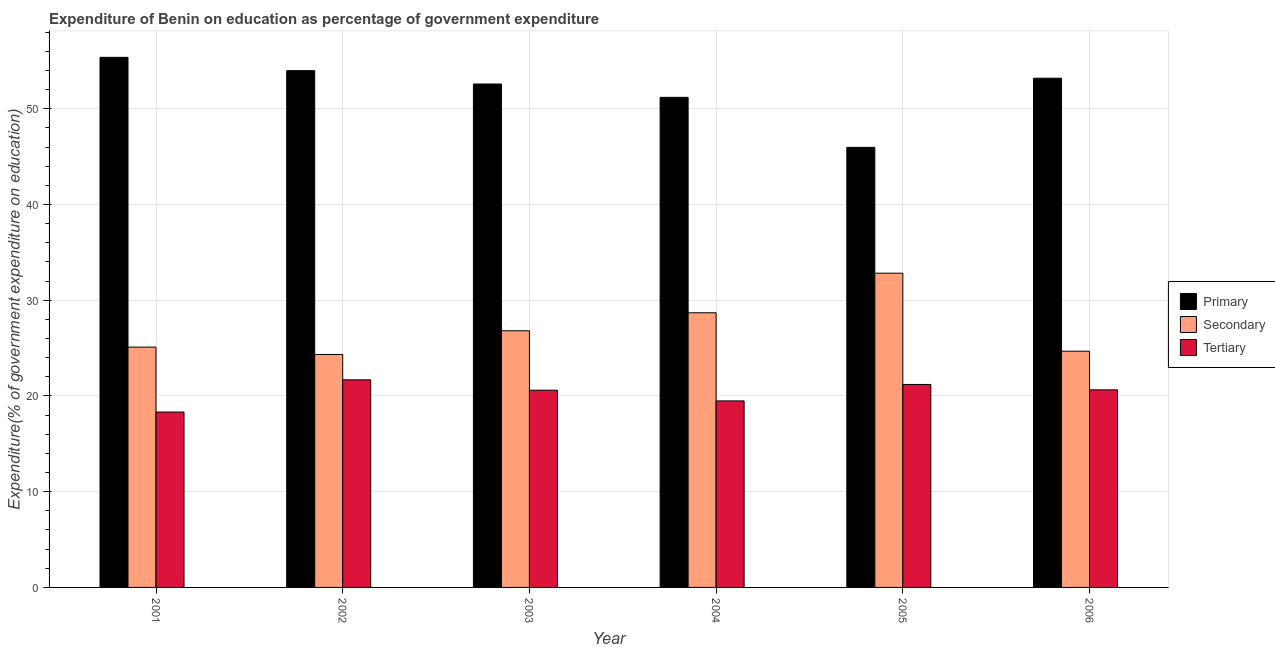How many different coloured bars are there?
Offer a very short reply. 3. How many groups of bars are there?
Keep it short and to the point. 6. Are the number of bars on each tick of the X-axis equal?
Ensure brevity in your answer.  Yes. What is the expenditure on secondary education in 2006?
Offer a very short reply. 24.68. Across all years, what is the maximum expenditure on secondary education?
Offer a terse response. 32.83. Across all years, what is the minimum expenditure on secondary education?
Ensure brevity in your answer.  24.33. In which year was the expenditure on secondary education minimum?
Give a very brief answer. 2002. What is the total expenditure on tertiary education in the graph?
Your response must be concise. 121.93. What is the difference between the expenditure on tertiary education in 2001 and that in 2002?
Your response must be concise. -3.37. What is the difference between the expenditure on primary education in 2004 and the expenditure on secondary education in 2005?
Keep it short and to the point. 5.23. What is the average expenditure on primary education per year?
Provide a succinct answer. 52.05. In how many years, is the expenditure on secondary education greater than 32 %?
Your answer should be compact. 1. What is the ratio of the expenditure on tertiary education in 2001 to that in 2005?
Keep it short and to the point. 0.86. Is the expenditure on secondary education in 2001 less than that in 2003?
Make the answer very short. Yes. What is the difference between the highest and the second highest expenditure on secondary education?
Provide a short and direct response. 4.14. What is the difference between the highest and the lowest expenditure on primary education?
Your response must be concise. 9.4. In how many years, is the expenditure on secondary education greater than the average expenditure on secondary education taken over all years?
Offer a terse response. 2. Is the sum of the expenditure on secondary education in 2001 and 2006 greater than the maximum expenditure on tertiary education across all years?
Give a very brief answer. Yes. What does the 3rd bar from the left in 2003 represents?
Offer a very short reply. Tertiary. What does the 2nd bar from the right in 2001 represents?
Your answer should be compact. Secondary. Does the graph contain grids?
Offer a terse response. Yes. How many legend labels are there?
Your response must be concise. 3. What is the title of the graph?
Offer a terse response. Expenditure of Benin on education as percentage of government expenditure. Does "Liquid fuel" appear as one of the legend labels in the graph?
Ensure brevity in your answer.  No. What is the label or title of the Y-axis?
Your response must be concise. Expenditure(% of government expenditure on education). What is the Expenditure(% of government expenditure on education) in Primary in 2001?
Provide a short and direct response. 55.37. What is the Expenditure(% of government expenditure on education) in Secondary in 2001?
Offer a very short reply. 25.1. What is the Expenditure(% of government expenditure on education) of Tertiary in 2001?
Keep it short and to the point. 18.32. What is the Expenditure(% of government expenditure on education) in Primary in 2002?
Ensure brevity in your answer.  53.98. What is the Expenditure(% of government expenditure on education) of Secondary in 2002?
Your response must be concise. 24.33. What is the Expenditure(% of government expenditure on education) in Tertiary in 2002?
Offer a very short reply. 21.69. What is the Expenditure(% of government expenditure on education) in Primary in 2003?
Offer a very short reply. 52.59. What is the Expenditure(% of government expenditure on education) of Secondary in 2003?
Keep it short and to the point. 26.81. What is the Expenditure(% of government expenditure on education) in Tertiary in 2003?
Your answer should be compact. 20.6. What is the Expenditure(% of government expenditure on education) in Primary in 2004?
Give a very brief answer. 51.2. What is the Expenditure(% of government expenditure on education) of Secondary in 2004?
Offer a terse response. 28.69. What is the Expenditure(% of government expenditure on education) of Tertiary in 2004?
Offer a terse response. 19.48. What is the Expenditure(% of government expenditure on education) in Primary in 2005?
Provide a short and direct response. 45.97. What is the Expenditure(% of government expenditure on education) of Secondary in 2005?
Make the answer very short. 32.83. What is the Expenditure(% of government expenditure on education) in Tertiary in 2005?
Provide a short and direct response. 21.2. What is the Expenditure(% of government expenditure on education) in Primary in 2006?
Your answer should be very brief. 53.19. What is the Expenditure(% of government expenditure on education) in Secondary in 2006?
Offer a very short reply. 24.68. What is the Expenditure(% of government expenditure on education) of Tertiary in 2006?
Provide a short and direct response. 20.64. Across all years, what is the maximum Expenditure(% of government expenditure on education) in Primary?
Keep it short and to the point. 55.37. Across all years, what is the maximum Expenditure(% of government expenditure on education) in Secondary?
Make the answer very short. 32.83. Across all years, what is the maximum Expenditure(% of government expenditure on education) of Tertiary?
Your answer should be compact. 21.69. Across all years, what is the minimum Expenditure(% of government expenditure on education) in Primary?
Ensure brevity in your answer.  45.97. Across all years, what is the minimum Expenditure(% of government expenditure on education) of Secondary?
Offer a terse response. 24.33. Across all years, what is the minimum Expenditure(% of government expenditure on education) in Tertiary?
Keep it short and to the point. 18.32. What is the total Expenditure(% of government expenditure on education) in Primary in the graph?
Offer a very short reply. 312.3. What is the total Expenditure(% of government expenditure on education) of Secondary in the graph?
Provide a short and direct response. 162.44. What is the total Expenditure(% of government expenditure on education) of Tertiary in the graph?
Your response must be concise. 121.93. What is the difference between the Expenditure(% of government expenditure on education) in Primary in 2001 and that in 2002?
Your response must be concise. 1.39. What is the difference between the Expenditure(% of government expenditure on education) in Secondary in 2001 and that in 2002?
Your response must be concise. 0.77. What is the difference between the Expenditure(% of government expenditure on education) of Tertiary in 2001 and that in 2002?
Your answer should be very brief. -3.37. What is the difference between the Expenditure(% of government expenditure on education) in Primary in 2001 and that in 2003?
Keep it short and to the point. 2.79. What is the difference between the Expenditure(% of government expenditure on education) in Secondary in 2001 and that in 2003?
Keep it short and to the point. -1.71. What is the difference between the Expenditure(% of government expenditure on education) in Tertiary in 2001 and that in 2003?
Provide a succinct answer. -2.28. What is the difference between the Expenditure(% of government expenditure on education) of Primary in 2001 and that in 2004?
Keep it short and to the point. 4.18. What is the difference between the Expenditure(% of government expenditure on education) of Secondary in 2001 and that in 2004?
Make the answer very short. -3.59. What is the difference between the Expenditure(% of government expenditure on education) in Tertiary in 2001 and that in 2004?
Give a very brief answer. -1.16. What is the difference between the Expenditure(% of government expenditure on education) of Primary in 2001 and that in 2005?
Make the answer very short. 9.4. What is the difference between the Expenditure(% of government expenditure on education) of Secondary in 2001 and that in 2005?
Offer a terse response. -7.72. What is the difference between the Expenditure(% of government expenditure on education) in Tertiary in 2001 and that in 2005?
Give a very brief answer. -2.88. What is the difference between the Expenditure(% of government expenditure on education) of Primary in 2001 and that in 2006?
Your answer should be compact. 2.18. What is the difference between the Expenditure(% of government expenditure on education) of Secondary in 2001 and that in 2006?
Provide a succinct answer. 0.43. What is the difference between the Expenditure(% of government expenditure on education) of Tertiary in 2001 and that in 2006?
Your response must be concise. -2.32. What is the difference between the Expenditure(% of government expenditure on education) of Primary in 2002 and that in 2003?
Your response must be concise. 1.39. What is the difference between the Expenditure(% of government expenditure on education) in Secondary in 2002 and that in 2003?
Provide a short and direct response. -2.48. What is the difference between the Expenditure(% of government expenditure on education) of Tertiary in 2002 and that in 2003?
Keep it short and to the point. 1.08. What is the difference between the Expenditure(% of government expenditure on education) in Primary in 2002 and that in 2004?
Offer a very short reply. 2.79. What is the difference between the Expenditure(% of government expenditure on education) of Secondary in 2002 and that in 2004?
Your answer should be very brief. -4.36. What is the difference between the Expenditure(% of government expenditure on education) of Tertiary in 2002 and that in 2004?
Your answer should be compact. 2.2. What is the difference between the Expenditure(% of government expenditure on education) in Primary in 2002 and that in 2005?
Offer a terse response. 8.01. What is the difference between the Expenditure(% of government expenditure on education) of Secondary in 2002 and that in 2005?
Your answer should be very brief. -8.49. What is the difference between the Expenditure(% of government expenditure on education) in Tertiary in 2002 and that in 2005?
Make the answer very short. 0.48. What is the difference between the Expenditure(% of government expenditure on education) in Primary in 2002 and that in 2006?
Ensure brevity in your answer.  0.79. What is the difference between the Expenditure(% of government expenditure on education) of Secondary in 2002 and that in 2006?
Ensure brevity in your answer.  -0.34. What is the difference between the Expenditure(% of government expenditure on education) of Tertiary in 2002 and that in 2006?
Offer a very short reply. 1.04. What is the difference between the Expenditure(% of government expenditure on education) of Primary in 2003 and that in 2004?
Your answer should be very brief. 1.39. What is the difference between the Expenditure(% of government expenditure on education) in Secondary in 2003 and that in 2004?
Offer a terse response. -1.88. What is the difference between the Expenditure(% of government expenditure on education) of Tertiary in 2003 and that in 2004?
Give a very brief answer. 1.12. What is the difference between the Expenditure(% of government expenditure on education) of Primary in 2003 and that in 2005?
Your answer should be compact. 6.62. What is the difference between the Expenditure(% of government expenditure on education) in Secondary in 2003 and that in 2005?
Give a very brief answer. -6.02. What is the difference between the Expenditure(% of government expenditure on education) in Tertiary in 2003 and that in 2005?
Your response must be concise. -0.6. What is the difference between the Expenditure(% of government expenditure on education) in Primary in 2003 and that in 2006?
Make the answer very short. -0.6. What is the difference between the Expenditure(% of government expenditure on education) of Secondary in 2003 and that in 2006?
Give a very brief answer. 2.13. What is the difference between the Expenditure(% of government expenditure on education) in Tertiary in 2003 and that in 2006?
Offer a terse response. -0.04. What is the difference between the Expenditure(% of government expenditure on education) of Primary in 2004 and that in 2005?
Offer a very short reply. 5.23. What is the difference between the Expenditure(% of government expenditure on education) of Secondary in 2004 and that in 2005?
Your answer should be very brief. -4.14. What is the difference between the Expenditure(% of government expenditure on education) in Tertiary in 2004 and that in 2005?
Offer a very short reply. -1.72. What is the difference between the Expenditure(% of government expenditure on education) of Primary in 2004 and that in 2006?
Make the answer very short. -2. What is the difference between the Expenditure(% of government expenditure on education) in Secondary in 2004 and that in 2006?
Your answer should be compact. 4.01. What is the difference between the Expenditure(% of government expenditure on education) in Tertiary in 2004 and that in 2006?
Give a very brief answer. -1.16. What is the difference between the Expenditure(% of government expenditure on education) in Primary in 2005 and that in 2006?
Offer a very short reply. -7.22. What is the difference between the Expenditure(% of government expenditure on education) in Secondary in 2005 and that in 2006?
Offer a terse response. 8.15. What is the difference between the Expenditure(% of government expenditure on education) of Tertiary in 2005 and that in 2006?
Keep it short and to the point. 0.56. What is the difference between the Expenditure(% of government expenditure on education) of Primary in 2001 and the Expenditure(% of government expenditure on education) of Secondary in 2002?
Ensure brevity in your answer.  31.04. What is the difference between the Expenditure(% of government expenditure on education) of Primary in 2001 and the Expenditure(% of government expenditure on education) of Tertiary in 2002?
Make the answer very short. 33.69. What is the difference between the Expenditure(% of government expenditure on education) of Secondary in 2001 and the Expenditure(% of government expenditure on education) of Tertiary in 2002?
Provide a short and direct response. 3.42. What is the difference between the Expenditure(% of government expenditure on education) in Primary in 2001 and the Expenditure(% of government expenditure on education) in Secondary in 2003?
Provide a succinct answer. 28.56. What is the difference between the Expenditure(% of government expenditure on education) in Primary in 2001 and the Expenditure(% of government expenditure on education) in Tertiary in 2003?
Your response must be concise. 34.77. What is the difference between the Expenditure(% of government expenditure on education) in Secondary in 2001 and the Expenditure(% of government expenditure on education) in Tertiary in 2003?
Your answer should be very brief. 4.5. What is the difference between the Expenditure(% of government expenditure on education) of Primary in 2001 and the Expenditure(% of government expenditure on education) of Secondary in 2004?
Keep it short and to the point. 26.68. What is the difference between the Expenditure(% of government expenditure on education) of Primary in 2001 and the Expenditure(% of government expenditure on education) of Tertiary in 2004?
Offer a very short reply. 35.89. What is the difference between the Expenditure(% of government expenditure on education) in Secondary in 2001 and the Expenditure(% of government expenditure on education) in Tertiary in 2004?
Give a very brief answer. 5.62. What is the difference between the Expenditure(% of government expenditure on education) in Primary in 2001 and the Expenditure(% of government expenditure on education) in Secondary in 2005?
Offer a very short reply. 22.55. What is the difference between the Expenditure(% of government expenditure on education) of Primary in 2001 and the Expenditure(% of government expenditure on education) of Tertiary in 2005?
Your answer should be compact. 34.17. What is the difference between the Expenditure(% of government expenditure on education) in Secondary in 2001 and the Expenditure(% of government expenditure on education) in Tertiary in 2005?
Offer a very short reply. 3.9. What is the difference between the Expenditure(% of government expenditure on education) of Primary in 2001 and the Expenditure(% of government expenditure on education) of Secondary in 2006?
Make the answer very short. 30.7. What is the difference between the Expenditure(% of government expenditure on education) in Primary in 2001 and the Expenditure(% of government expenditure on education) in Tertiary in 2006?
Your response must be concise. 34.73. What is the difference between the Expenditure(% of government expenditure on education) of Secondary in 2001 and the Expenditure(% of government expenditure on education) of Tertiary in 2006?
Provide a succinct answer. 4.46. What is the difference between the Expenditure(% of government expenditure on education) in Primary in 2002 and the Expenditure(% of government expenditure on education) in Secondary in 2003?
Your answer should be very brief. 27.17. What is the difference between the Expenditure(% of government expenditure on education) in Primary in 2002 and the Expenditure(% of government expenditure on education) in Tertiary in 2003?
Provide a succinct answer. 33.38. What is the difference between the Expenditure(% of government expenditure on education) of Secondary in 2002 and the Expenditure(% of government expenditure on education) of Tertiary in 2003?
Offer a terse response. 3.73. What is the difference between the Expenditure(% of government expenditure on education) in Primary in 2002 and the Expenditure(% of government expenditure on education) in Secondary in 2004?
Your answer should be compact. 25.29. What is the difference between the Expenditure(% of government expenditure on education) in Primary in 2002 and the Expenditure(% of government expenditure on education) in Tertiary in 2004?
Give a very brief answer. 34.5. What is the difference between the Expenditure(% of government expenditure on education) in Secondary in 2002 and the Expenditure(% of government expenditure on education) in Tertiary in 2004?
Ensure brevity in your answer.  4.85. What is the difference between the Expenditure(% of government expenditure on education) of Primary in 2002 and the Expenditure(% of government expenditure on education) of Secondary in 2005?
Keep it short and to the point. 21.15. What is the difference between the Expenditure(% of government expenditure on education) in Primary in 2002 and the Expenditure(% of government expenditure on education) in Tertiary in 2005?
Your response must be concise. 32.78. What is the difference between the Expenditure(% of government expenditure on education) in Secondary in 2002 and the Expenditure(% of government expenditure on education) in Tertiary in 2005?
Keep it short and to the point. 3.13. What is the difference between the Expenditure(% of government expenditure on education) in Primary in 2002 and the Expenditure(% of government expenditure on education) in Secondary in 2006?
Provide a short and direct response. 29.31. What is the difference between the Expenditure(% of government expenditure on education) of Primary in 2002 and the Expenditure(% of government expenditure on education) of Tertiary in 2006?
Offer a very short reply. 33.34. What is the difference between the Expenditure(% of government expenditure on education) in Secondary in 2002 and the Expenditure(% of government expenditure on education) in Tertiary in 2006?
Keep it short and to the point. 3.69. What is the difference between the Expenditure(% of government expenditure on education) in Primary in 2003 and the Expenditure(% of government expenditure on education) in Secondary in 2004?
Ensure brevity in your answer.  23.9. What is the difference between the Expenditure(% of government expenditure on education) of Primary in 2003 and the Expenditure(% of government expenditure on education) of Tertiary in 2004?
Keep it short and to the point. 33.1. What is the difference between the Expenditure(% of government expenditure on education) of Secondary in 2003 and the Expenditure(% of government expenditure on education) of Tertiary in 2004?
Ensure brevity in your answer.  7.33. What is the difference between the Expenditure(% of government expenditure on education) in Primary in 2003 and the Expenditure(% of government expenditure on education) in Secondary in 2005?
Offer a terse response. 19.76. What is the difference between the Expenditure(% of government expenditure on education) of Primary in 2003 and the Expenditure(% of government expenditure on education) of Tertiary in 2005?
Make the answer very short. 31.39. What is the difference between the Expenditure(% of government expenditure on education) of Secondary in 2003 and the Expenditure(% of government expenditure on education) of Tertiary in 2005?
Provide a short and direct response. 5.61. What is the difference between the Expenditure(% of government expenditure on education) of Primary in 2003 and the Expenditure(% of government expenditure on education) of Secondary in 2006?
Provide a short and direct response. 27.91. What is the difference between the Expenditure(% of government expenditure on education) of Primary in 2003 and the Expenditure(% of government expenditure on education) of Tertiary in 2006?
Your response must be concise. 31.95. What is the difference between the Expenditure(% of government expenditure on education) of Secondary in 2003 and the Expenditure(% of government expenditure on education) of Tertiary in 2006?
Your response must be concise. 6.17. What is the difference between the Expenditure(% of government expenditure on education) of Primary in 2004 and the Expenditure(% of government expenditure on education) of Secondary in 2005?
Keep it short and to the point. 18.37. What is the difference between the Expenditure(% of government expenditure on education) of Primary in 2004 and the Expenditure(% of government expenditure on education) of Tertiary in 2005?
Offer a very short reply. 29.99. What is the difference between the Expenditure(% of government expenditure on education) in Secondary in 2004 and the Expenditure(% of government expenditure on education) in Tertiary in 2005?
Offer a terse response. 7.49. What is the difference between the Expenditure(% of government expenditure on education) of Primary in 2004 and the Expenditure(% of government expenditure on education) of Secondary in 2006?
Keep it short and to the point. 26.52. What is the difference between the Expenditure(% of government expenditure on education) in Primary in 2004 and the Expenditure(% of government expenditure on education) in Tertiary in 2006?
Provide a short and direct response. 30.55. What is the difference between the Expenditure(% of government expenditure on education) of Secondary in 2004 and the Expenditure(% of government expenditure on education) of Tertiary in 2006?
Provide a succinct answer. 8.05. What is the difference between the Expenditure(% of government expenditure on education) in Primary in 2005 and the Expenditure(% of government expenditure on education) in Secondary in 2006?
Your response must be concise. 21.29. What is the difference between the Expenditure(% of government expenditure on education) in Primary in 2005 and the Expenditure(% of government expenditure on education) in Tertiary in 2006?
Provide a succinct answer. 25.33. What is the difference between the Expenditure(% of government expenditure on education) of Secondary in 2005 and the Expenditure(% of government expenditure on education) of Tertiary in 2006?
Your answer should be compact. 12.19. What is the average Expenditure(% of government expenditure on education) of Primary per year?
Ensure brevity in your answer.  52.05. What is the average Expenditure(% of government expenditure on education) in Secondary per year?
Make the answer very short. 27.07. What is the average Expenditure(% of government expenditure on education) of Tertiary per year?
Provide a short and direct response. 20.32. In the year 2001, what is the difference between the Expenditure(% of government expenditure on education) in Primary and Expenditure(% of government expenditure on education) in Secondary?
Your answer should be compact. 30.27. In the year 2001, what is the difference between the Expenditure(% of government expenditure on education) in Primary and Expenditure(% of government expenditure on education) in Tertiary?
Ensure brevity in your answer.  37.05. In the year 2001, what is the difference between the Expenditure(% of government expenditure on education) in Secondary and Expenditure(% of government expenditure on education) in Tertiary?
Make the answer very short. 6.78. In the year 2002, what is the difference between the Expenditure(% of government expenditure on education) in Primary and Expenditure(% of government expenditure on education) in Secondary?
Ensure brevity in your answer.  29.65. In the year 2002, what is the difference between the Expenditure(% of government expenditure on education) in Primary and Expenditure(% of government expenditure on education) in Tertiary?
Keep it short and to the point. 32.3. In the year 2002, what is the difference between the Expenditure(% of government expenditure on education) of Secondary and Expenditure(% of government expenditure on education) of Tertiary?
Your answer should be very brief. 2.65. In the year 2003, what is the difference between the Expenditure(% of government expenditure on education) of Primary and Expenditure(% of government expenditure on education) of Secondary?
Ensure brevity in your answer.  25.78. In the year 2003, what is the difference between the Expenditure(% of government expenditure on education) of Primary and Expenditure(% of government expenditure on education) of Tertiary?
Your answer should be compact. 31.99. In the year 2003, what is the difference between the Expenditure(% of government expenditure on education) in Secondary and Expenditure(% of government expenditure on education) in Tertiary?
Offer a very short reply. 6.21. In the year 2004, what is the difference between the Expenditure(% of government expenditure on education) of Primary and Expenditure(% of government expenditure on education) of Secondary?
Provide a short and direct response. 22.5. In the year 2004, what is the difference between the Expenditure(% of government expenditure on education) in Primary and Expenditure(% of government expenditure on education) in Tertiary?
Your response must be concise. 31.71. In the year 2004, what is the difference between the Expenditure(% of government expenditure on education) in Secondary and Expenditure(% of government expenditure on education) in Tertiary?
Your answer should be very brief. 9.21. In the year 2005, what is the difference between the Expenditure(% of government expenditure on education) in Primary and Expenditure(% of government expenditure on education) in Secondary?
Ensure brevity in your answer.  13.14. In the year 2005, what is the difference between the Expenditure(% of government expenditure on education) in Primary and Expenditure(% of government expenditure on education) in Tertiary?
Provide a succinct answer. 24.77. In the year 2005, what is the difference between the Expenditure(% of government expenditure on education) in Secondary and Expenditure(% of government expenditure on education) in Tertiary?
Your response must be concise. 11.62. In the year 2006, what is the difference between the Expenditure(% of government expenditure on education) of Primary and Expenditure(% of government expenditure on education) of Secondary?
Keep it short and to the point. 28.52. In the year 2006, what is the difference between the Expenditure(% of government expenditure on education) of Primary and Expenditure(% of government expenditure on education) of Tertiary?
Ensure brevity in your answer.  32.55. In the year 2006, what is the difference between the Expenditure(% of government expenditure on education) in Secondary and Expenditure(% of government expenditure on education) in Tertiary?
Offer a terse response. 4.04. What is the ratio of the Expenditure(% of government expenditure on education) of Primary in 2001 to that in 2002?
Provide a short and direct response. 1.03. What is the ratio of the Expenditure(% of government expenditure on education) in Secondary in 2001 to that in 2002?
Offer a terse response. 1.03. What is the ratio of the Expenditure(% of government expenditure on education) of Tertiary in 2001 to that in 2002?
Ensure brevity in your answer.  0.84. What is the ratio of the Expenditure(% of government expenditure on education) in Primary in 2001 to that in 2003?
Make the answer very short. 1.05. What is the ratio of the Expenditure(% of government expenditure on education) in Secondary in 2001 to that in 2003?
Offer a terse response. 0.94. What is the ratio of the Expenditure(% of government expenditure on education) in Tertiary in 2001 to that in 2003?
Ensure brevity in your answer.  0.89. What is the ratio of the Expenditure(% of government expenditure on education) in Primary in 2001 to that in 2004?
Keep it short and to the point. 1.08. What is the ratio of the Expenditure(% of government expenditure on education) of Secondary in 2001 to that in 2004?
Your response must be concise. 0.88. What is the ratio of the Expenditure(% of government expenditure on education) in Tertiary in 2001 to that in 2004?
Provide a succinct answer. 0.94. What is the ratio of the Expenditure(% of government expenditure on education) of Primary in 2001 to that in 2005?
Offer a very short reply. 1.2. What is the ratio of the Expenditure(% of government expenditure on education) of Secondary in 2001 to that in 2005?
Provide a succinct answer. 0.76. What is the ratio of the Expenditure(% of government expenditure on education) of Tertiary in 2001 to that in 2005?
Offer a very short reply. 0.86. What is the ratio of the Expenditure(% of government expenditure on education) in Primary in 2001 to that in 2006?
Offer a very short reply. 1.04. What is the ratio of the Expenditure(% of government expenditure on education) of Secondary in 2001 to that in 2006?
Provide a short and direct response. 1.02. What is the ratio of the Expenditure(% of government expenditure on education) of Tertiary in 2001 to that in 2006?
Your answer should be compact. 0.89. What is the ratio of the Expenditure(% of government expenditure on education) in Primary in 2002 to that in 2003?
Ensure brevity in your answer.  1.03. What is the ratio of the Expenditure(% of government expenditure on education) in Secondary in 2002 to that in 2003?
Your answer should be compact. 0.91. What is the ratio of the Expenditure(% of government expenditure on education) of Tertiary in 2002 to that in 2003?
Provide a succinct answer. 1.05. What is the ratio of the Expenditure(% of government expenditure on education) in Primary in 2002 to that in 2004?
Give a very brief answer. 1.05. What is the ratio of the Expenditure(% of government expenditure on education) in Secondary in 2002 to that in 2004?
Keep it short and to the point. 0.85. What is the ratio of the Expenditure(% of government expenditure on education) of Tertiary in 2002 to that in 2004?
Your answer should be very brief. 1.11. What is the ratio of the Expenditure(% of government expenditure on education) of Primary in 2002 to that in 2005?
Ensure brevity in your answer.  1.17. What is the ratio of the Expenditure(% of government expenditure on education) in Secondary in 2002 to that in 2005?
Your answer should be compact. 0.74. What is the ratio of the Expenditure(% of government expenditure on education) in Tertiary in 2002 to that in 2005?
Offer a terse response. 1.02. What is the ratio of the Expenditure(% of government expenditure on education) of Primary in 2002 to that in 2006?
Give a very brief answer. 1.01. What is the ratio of the Expenditure(% of government expenditure on education) in Secondary in 2002 to that in 2006?
Make the answer very short. 0.99. What is the ratio of the Expenditure(% of government expenditure on education) in Tertiary in 2002 to that in 2006?
Offer a terse response. 1.05. What is the ratio of the Expenditure(% of government expenditure on education) in Primary in 2003 to that in 2004?
Provide a short and direct response. 1.03. What is the ratio of the Expenditure(% of government expenditure on education) in Secondary in 2003 to that in 2004?
Offer a terse response. 0.93. What is the ratio of the Expenditure(% of government expenditure on education) of Tertiary in 2003 to that in 2004?
Your response must be concise. 1.06. What is the ratio of the Expenditure(% of government expenditure on education) in Primary in 2003 to that in 2005?
Give a very brief answer. 1.14. What is the ratio of the Expenditure(% of government expenditure on education) of Secondary in 2003 to that in 2005?
Your answer should be very brief. 0.82. What is the ratio of the Expenditure(% of government expenditure on education) in Tertiary in 2003 to that in 2005?
Your answer should be very brief. 0.97. What is the ratio of the Expenditure(% of government expenditure on education) of Secondary in 2003 to that in 2006?
Provide a short and direct response. 1.09. What is the ratio of the Expenditure(% of government expenditure on education) of Primary in 2004 to that in 2005?
Provide a succinct answer. 1.11. What is the ratio of the Expenditure(% of government expenditure on education) of Secondary in 2004 to that in 2005?
Provide a short and direct response. 0.87. What is the ratio of the Expenditure(% of government expenditure on education) in Tertiary in 2004 to that in 2005?
Provide a succinct answer. 0.92. What is the ratio of the Expenditure(% of government expenditure on education) of Primary in 2004 to that in 2006?
Offer a terse response. 0.96. What is the ratio of the Expenditure(% of government expenditure on education) in Secondary in 2004 to that in 2006?
Give a very brief answer. 1.16. What is the ratio of the Expenditure(% of government expenditure on education) of Tertiary in 2004 to that in 2006?
Offer a terse response. 0.94. What is the ratio of the Expenditure(% of government expenditure on education) in Primary in 2005 to that in 2006?
Offer a terse response. 0.86. What is the ratio of the Expenditure(% of government expenditure on education) of Secondary in 2005 to that in 2006?
Your answer should be compact. 1.33. What is the ratio of the Expenditure(% of government expenditure on education) of Tertiary in 2005 to that in 2006?
Provide a succinct answer. 1.03. What is the difference between the highest and the second highest Expenditure(% of government expenditure on education) of Primary?
Offer a very short reply. 1.39. What is the difference between the highest and the second highest Expenditure(% of government expenditure on education) of Secondary?
Offer a terse response. 4.14. What is the difference between the highest and the second highest Expenditure(% of government expenditure on education) in Tertiary?
Make the answer very short. 0.48. What is the difference between the highest and the lowest Expenditure(% of government expenditure on education) of Primary?
Your response must be concise. 9.4. What is the difference between the highest and the lowest Expenditure(% of government expenditure on education) of Secondary?
Provide a succinct answer. 8.49. What is the difference between the highest and the lowest Expenditure(% of government expenditure on education) in Tertiary?
Make the answer very short. 3.37. 